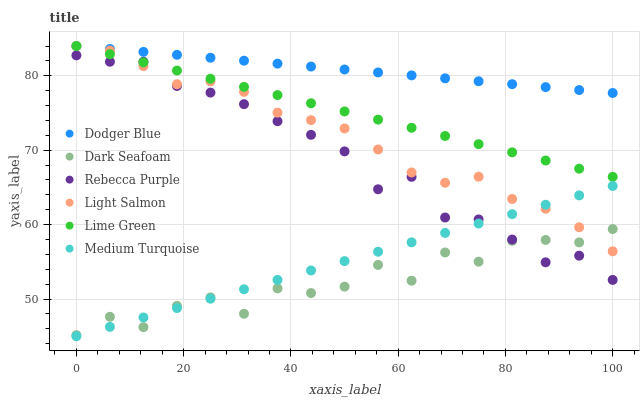Does Dark Seafoam have the minimum area under the curve?
Answer yes or no. Yes. Does Dodger Blue have the maximum area under the curve?
Answer yes or no. Yes. Does Dodger Blue have the minimum area under the curve?
Answer yes or no. No. Does Dark Seafoam have the maximum area under the curve?
Answer yes or no. No. Is Medium Turquoise the smoothest?
Answer yes or no. Yes. Is Dark Seafoam the roughest?
Answer yes or no. Yes. Is Dodger Blue the smoothest?
Answer yes or no. No. Is Dodger Blue the roughest?
Answer yes or no. No. Does Medium Turquoise have the lowest value?
Answer yes or no. Yes. Does Dark Seafoam have the lowest value?
Answer yes or no. No. Does Lime Green have the highest value?
Answer yes or no. Yes. Does Dark Seafoam have the highest value?
Answer yes or no. No. Is Medium Turquoise less than Lime Green?
Answer yes or no. Yes. Is Dodger Blue greater than Medium Turquoise?
Answer yes or no. Yes. Does Dark Seafoam intersect Light Salmon?
Answer yes or no. Yes. Is Dark Seafoam less than Light Salmon?
Answer yes or no. No. Is Dark Seafoam greater than Light Salmon?
Answer yes or no. No. Does Medium Turquoise intersect Lime Green?
Answer yes or no. No. 